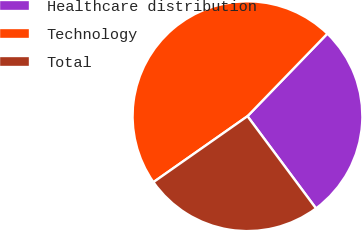Convert chart to OTSL. <chart><loc_0><loc_0><loc_500><loc_500><pie_chart><fcel>Healthcare distribution<fcel>Technology<fcel>Total<nl><fcel>27.59%<fcel>46.97%<fcel>25.44%<nl></chart> 